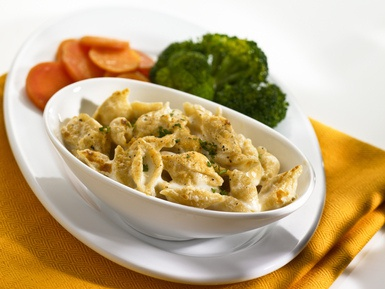Describe the objects in this image and their specific colors. I can see bowl in white, ivory, tan, and olive tones, broccoli in white, darkgreen, and olive tones, carrot in white, orange, red, and brown tones, carrot in white, red, brown, and lightgray tones, and carrot in white, red, maroon, and orange tones in this image. 